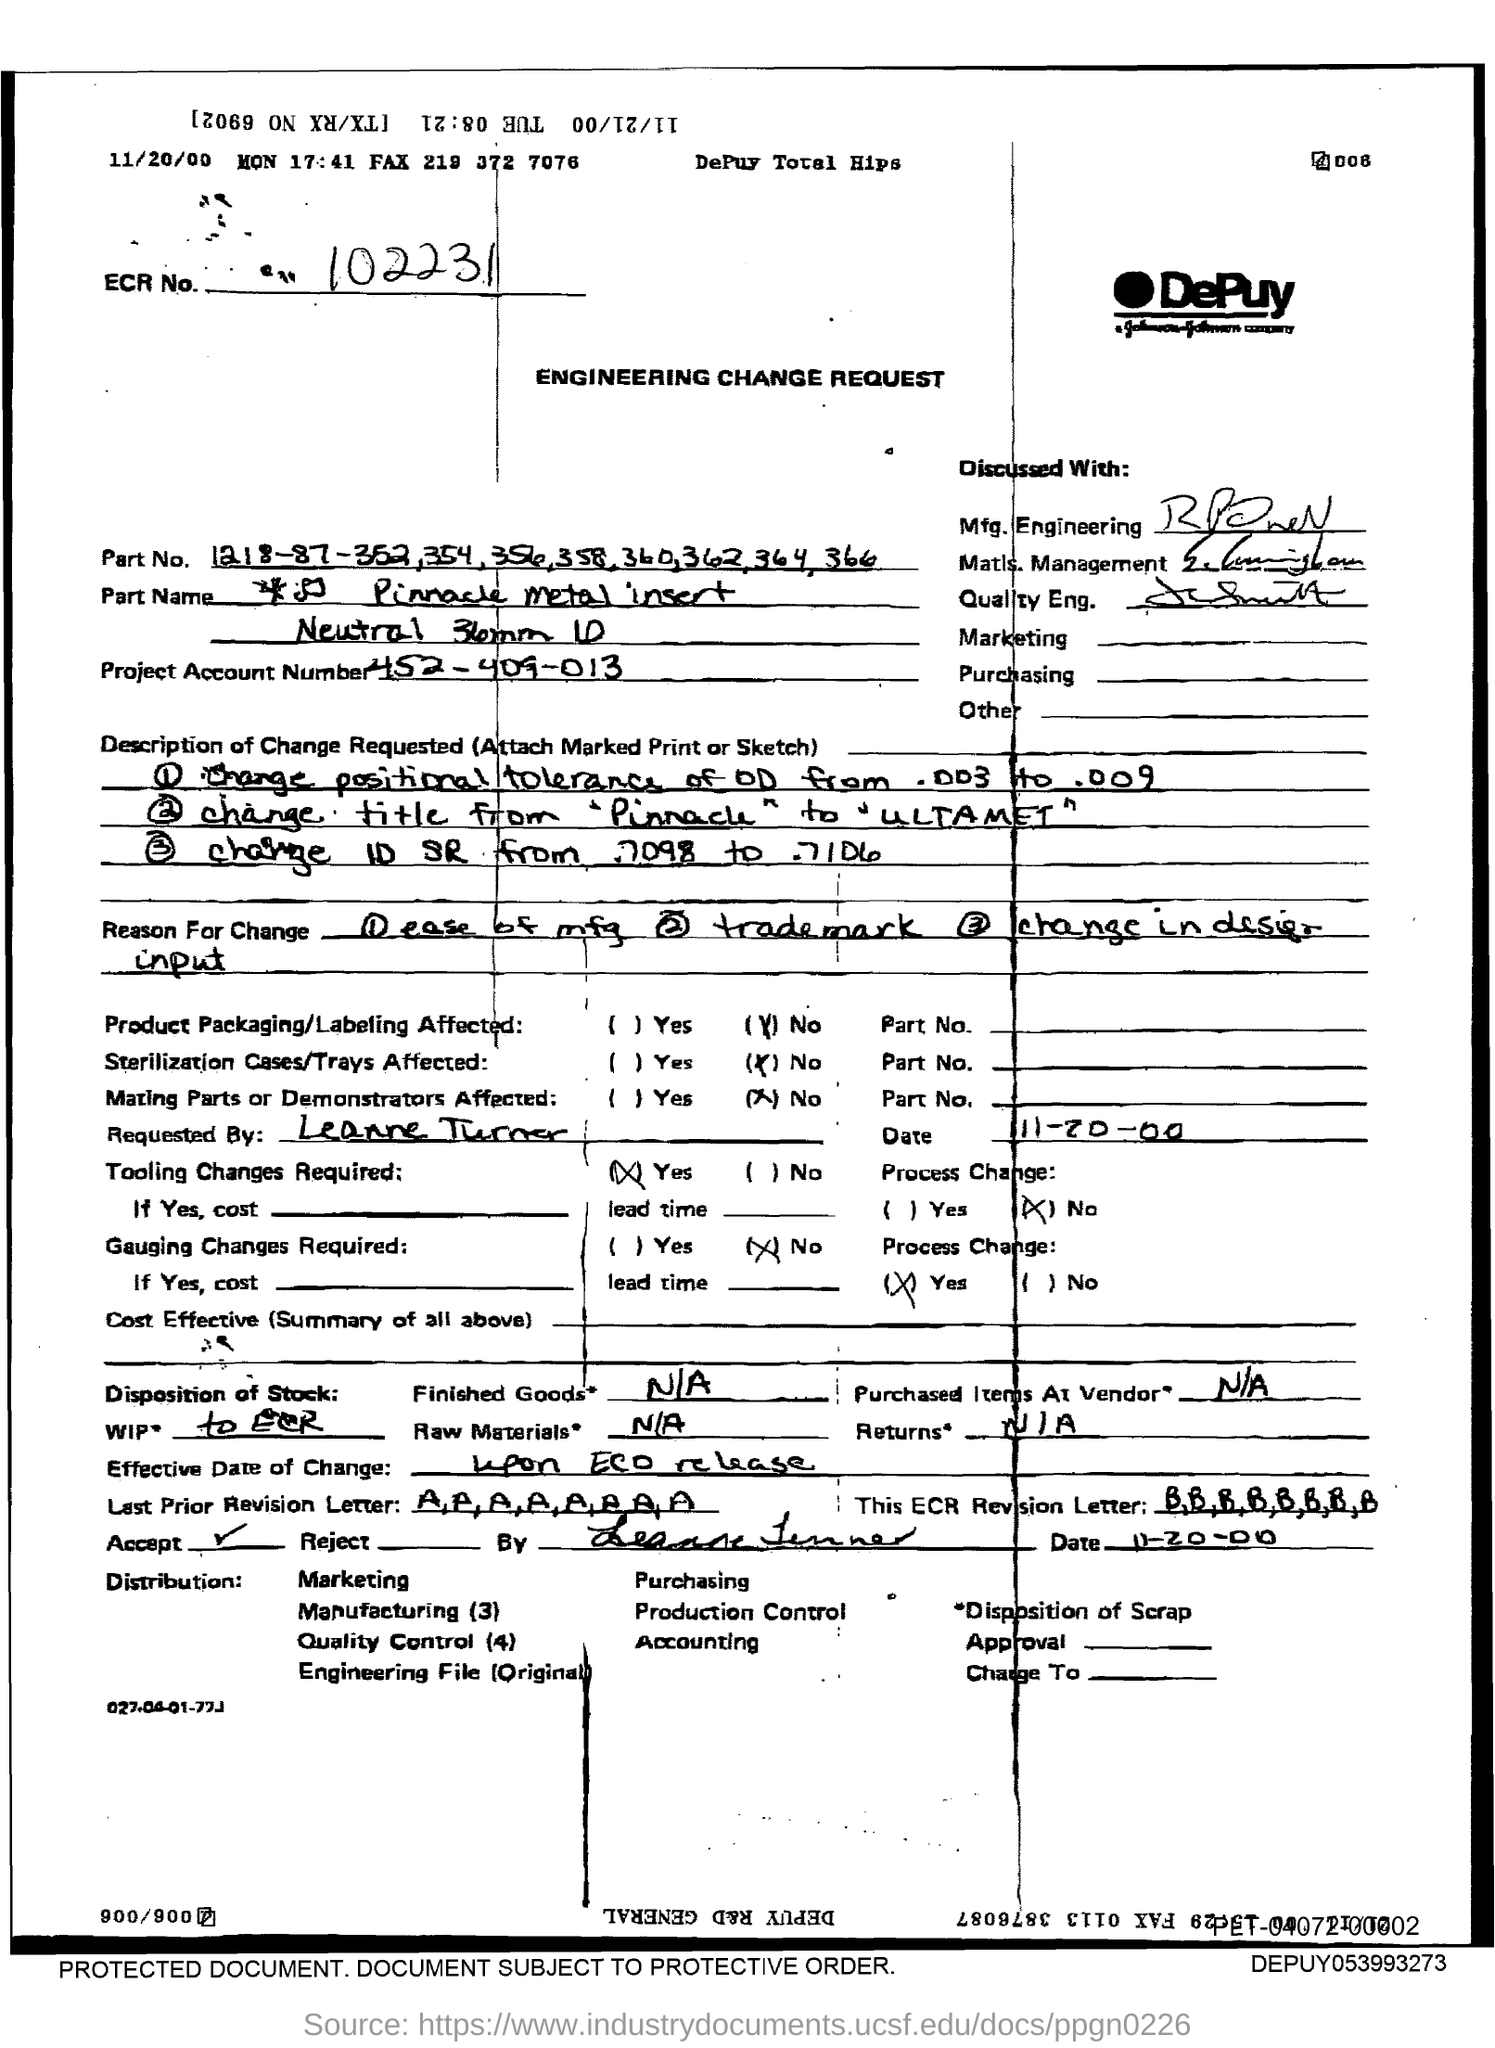Mention a couple of crucial points in this snapshot. The project account number is 452-409-013. The ECR number in the document is 102231... 